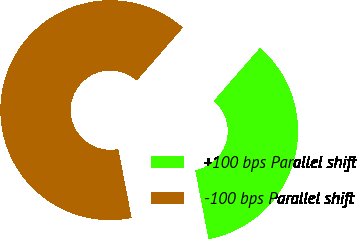Convert chart. <chart><loc_0><loc_0><loc_500><loc_500><pie_chart><fcel>+100 bps Parallel shift<fcel>-100 bps Parallel shift<nl><fcel>35.55%<fcel>64.45%<nl></chart> 